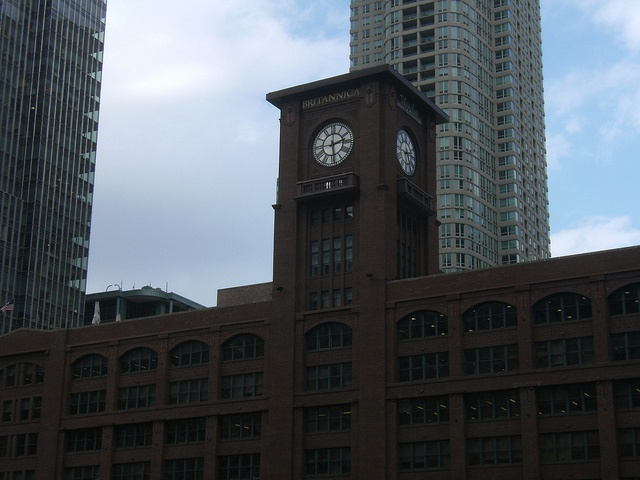Describe the objects in this image and their specific colors. I can see clock in black, gray, and darkgray tones and clock in black, gray, and blue tones in this image. 